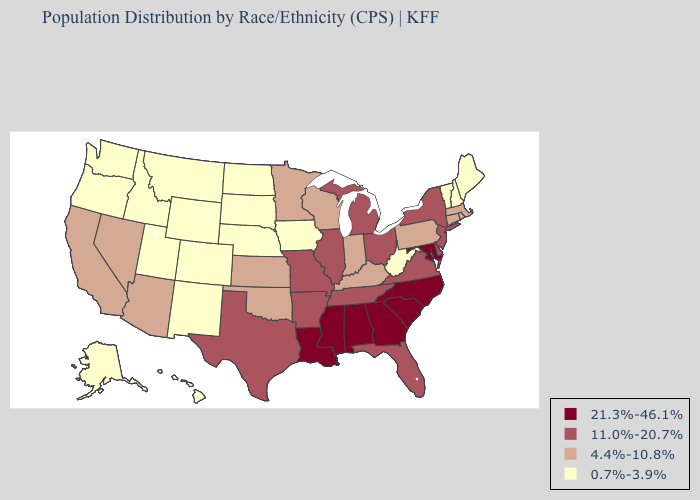What is the lowest value in the USA?
Answer briefly. 0.7%-3.9%. Does Kentucky have the same value as Maine?
Be succinct. No. What is the lowest value in the USA?
Answer briefly. 0.7%-3.9%. What is the highest value in the South ?
Short answer required. 21.3%-46.1%. What is the value of Iowa?
Keep it brief. 0.7%-3.9%. Name the states that have a value in the range 0.7%-3.9%?
Write a very short answer. Alaska, Colorado, Hawaii, Idaho, Iowa, Maine, Montana, Nebraska, New Hampshire, New Mexico, North Dakota, Oregon, South Dakota, Utah, Vermont, Washington, West Virginia, Wyoming. Name the states that have a value in the range 21.3%-46.1%?
Answer briefly. Alabama, Georgia, Louisiana, Maryland, Mississippi, North Carolina, South Carolina. Does Vermont have the lowest value in the Northeast?
Write a very short answer. Yes. What is the lowest value in states that border Alabama?
Answer briefly. 11.0%-20.7%. Name the states that have a value in the range 4.4%-10.8%?
Answer briefly. Arizona, California, Connecticut, Indiana, Kansas, Kentucky, Massachusetts, Minnesota, Nevada, Oklahoma, Pennsylvania, Rhode Island, Wisconsin. What is the value of Oregon?
Answer briefly. 0.7%-3.9%. What is the value of Kansas?
Concise answer only. 4.4%-10.8%. What is the value of Georgia?
Answer briefly. 21.3%-46.1%. What is the value of Maine?
Short answer required. 0.7%-3.9%. Name the states that have a value in the range 21.3%-46.1%?
Write a very short answer. Alabama, Georgia, Louisiana, Maryland, Mississippi, North Carolina, South Carolina. 